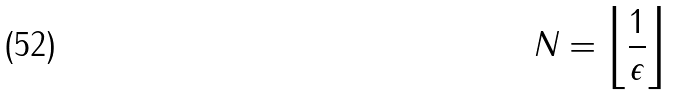<formula> <loc_0><loc_0><loc_500><loc_500>N = \left \lfloor { \frac { 1 } { \epsilon } } \right \rfloor</formula> 